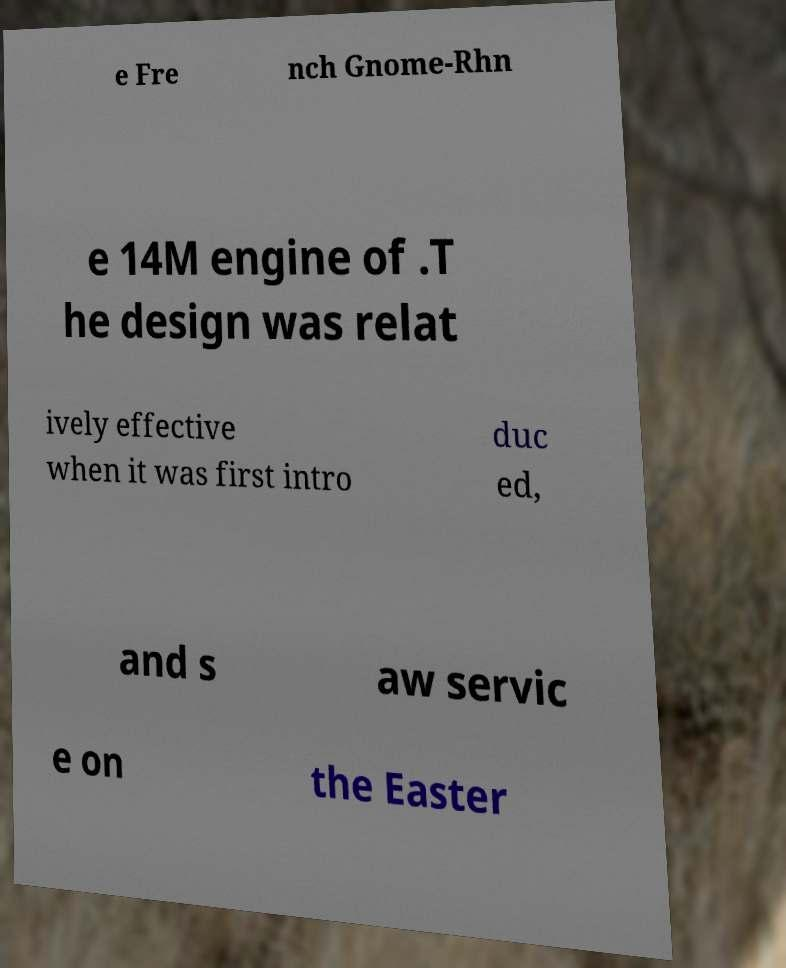Can you accurately transcribe the text from the provided image for me? e Fre nch Gnome-Rhn e 14M engine of .T he design was relat ively effective when it was first intro duc ed, and s aw servic e on the Easter 